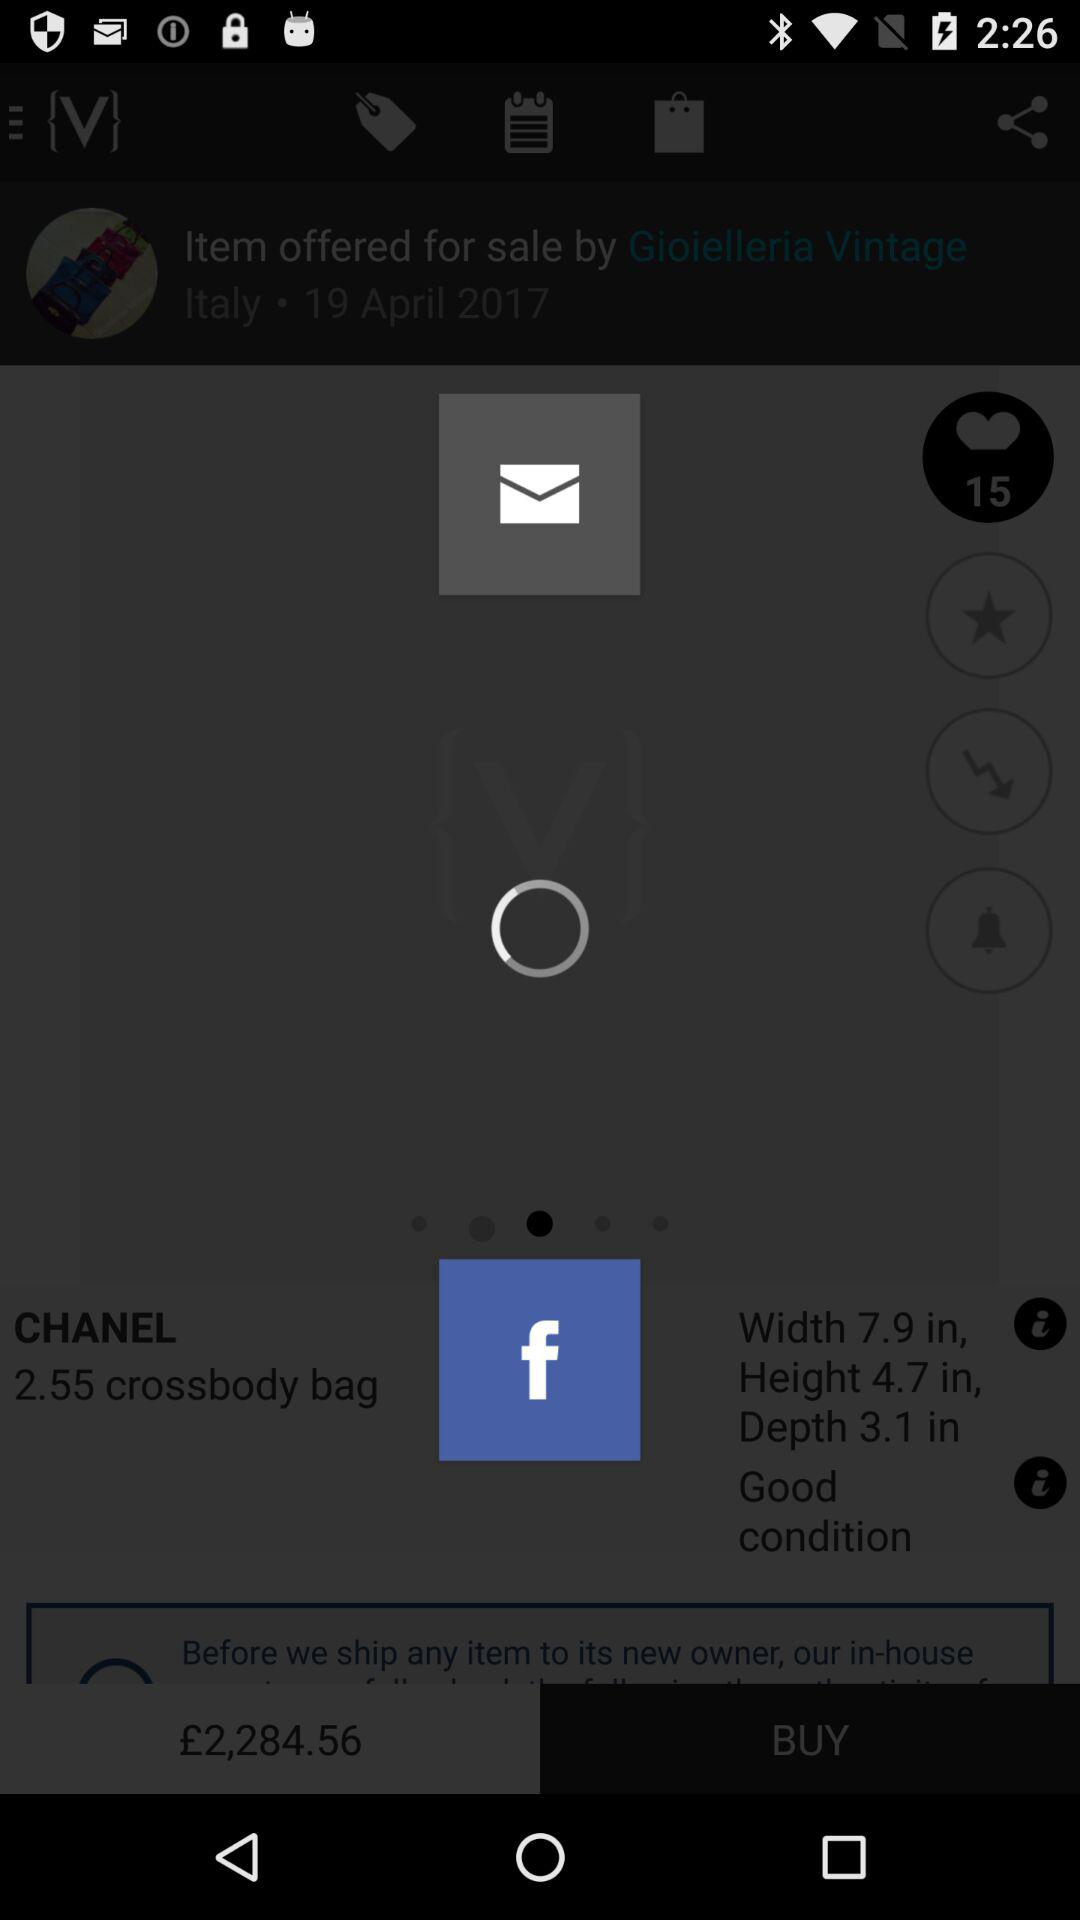How many more centimeters is the bag's width than its height?
Answer the question using a single word or phrase. 3.2 